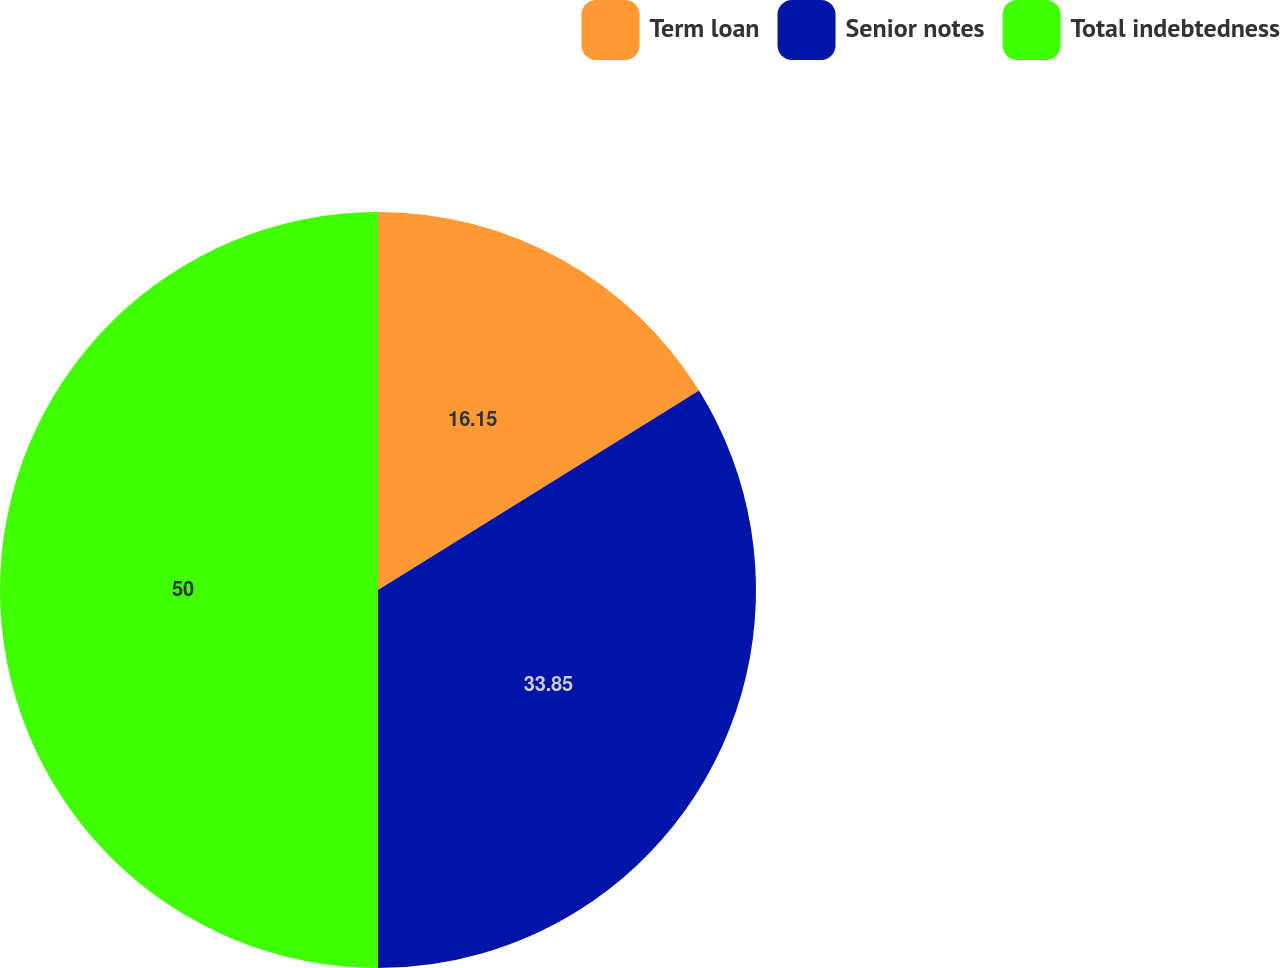Convert chart. <chart><loc_0><loc_0><loc_500><loc_500><pie_chart><fcel>Term loan<fcel>Senior notes<fcel>Total indebtedness<nl><fcel>16.15%<fcel>33.85%<fcel>50.0%<nl></chart> 